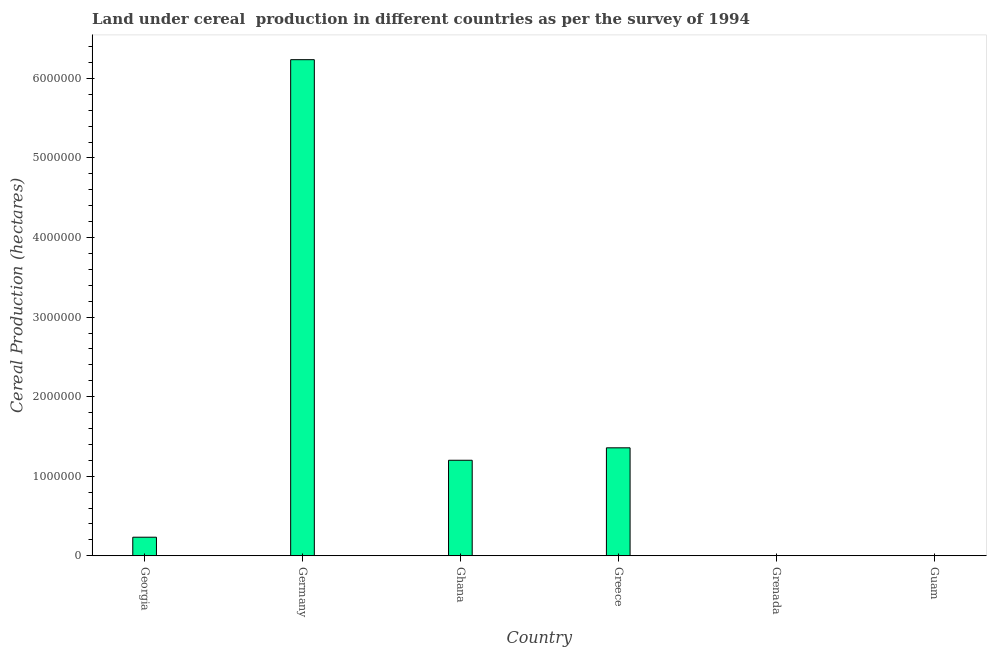Does the graph contain grids?
Provide a short and direct response. No. What is the title of the graph?
Provide a short and direct response. Land under cereal  production in different countries as per the survey of 1994. What is the label or title of the Y-axis?
Provide a succinct answer. Cereal Production (hectares). What is the land under cereal production in Germany?
Ensure brevity in your answer.  6.24e+06. Across all countries, what is the maximum land under cereal production?
Make the answer very short. 6.24e+06. In which country was the land under cereal production maximum?
Your answer should be compact. Germany. In which country was the land under cereal production minimum?
Keep it short and to the point. Guam. What is the sum of the land under cereal production?
Provide a succinct answer. 9.03e+06. What is the difference between the land under cereal production in Georgia and Greece?
Offer a terse response. -1.12e+06. What is the average land under cereal production per country?
Provide a short and direct response. 1.50e+06. What is the median land under cereal production?
Keep it short and to the point. 7.17e+05. What is the ratio of the land under cereal production in Germany to that in Guam?
Provide a succinct answer. 7.79e+05. Is the difference between the land under cereal production in Grenada and Guam greater than the difference between any two countries?
Offer a terse response. No. What is the difference between the highest and the second highest land under cereal production?
Give a very brief answer. 4.88e+06. What is the difference between the highest and the lowest land under cereal production?
Keep it short and to the point. 6.24e+06. How many bars are there?
Provide a succinct answer. 6. Are all the bars in the graph horizontal?
Make the answer very short. No. How many countries are there in the graph?
Offer a terse response. 6. What is the Cereal Production (hectares) of Georgia?
Make the answer very short. 2.34e+05. What is the Cereal Production (hectares) of Germany?
Ensure brevity in your answer.  6.24e+06. What is the Cereal Production (hectares) in Ghana?
Ensure brevity in your answer.  1.20e+06. What is the Cereal Production (hectares) in Greece?
Your answer should be very brief. 1.36e+06. What is the Cereal Production (hectares) of Grenada?
Keep it short and to the point. 350. What is the difference between the Cereal Production (hectares) in Georgia and Germany?
Make the answer very short. -6.00e+06. What is the difference between the Cereal Production (hectares) in Georgia and Ghana?
Make the answer very short. -9.67e+05. What is the difference between the Cereal Production (hectares) in Georgia and Greece?
Ensure brevity in your answer.  -1.12e+06. What is the difference between the Cereal Production (hectares) in Georgia and Grenada?
Provide a short and direct response. 2.33e+05. What is the difference between the Cereal Production (hectares) in Georgia and Guam?
Offer a terse response. 2.33e+05. What is the difference between the Cereal Production (hectares) in Germany and Ghana?
Ensure brevity in your answer.  5.03e+06. What is the difference between the Cereal Production (hectares) in Germany and Greece?
Your answer should be compact. 4.88e+06. What is the difference between the Cereal Production (hectares) in Germany and Grenada?
Offer a terse response. 6.23e+06. What is the difference between the Cereal Production (hectares) in Germany and Guam?
Ensure brevity in your answer.  6.24e+06. What is the difference between the Cereal Production (hectares) in Ghana and Greece?
Offer a terse response. -1.56e+05. What is the difference between the Cereal Production (hectares) in Ghana and Grenada?
Offer a terse response. 1.20e+06. What is the difference between the Cereal Production (hectares) in Ghana and Guam?
Provide a succinct answer. 1.20e+06. What is the difference between the Cereal Production (hectares) in Greece and Grenada?
Provide a succinct answer. 1.36e+06. What is the difference between the Cereal Production (hectares) in Greece and Guam?
Your response must be concise. 1.36e+06. What is the difference between the Cereal Production (hectares) in Grenada and Guam?
Your answer should be compact. 342. What is the ratio of the Cereal Production (hectares) in Georgia to that in Germany?
Your answer should be very brief. 0.04. What is the ratio of the Cereal Production (hectares) in Georgia to that in Ghana?
Provide a short and direct response. 0.19. What is the ratio of the Cereal Production (hectares) in Georgia to that in Greece?
Give a very brief answer. 0.17. What is the ratio of the Cereal Production (hectares) in Georgia to that in Grenada?
Make the answer very short. 667.15. What is the ratio of the Cereal Production (hectares) in Georgia to that in Guam?
Give a very brief answer. 2.92e+04. What is the ratio of the Cereal Production (hectares) in Germany to that in Ghana?
Your answer should be compact. 5.19. What is the ratio of the Cereal Production (hectares) in Germany to that in Greece?
Offer a very short reply. 4.59. What is the ratio of the Cereal Production (hectares) in Germany to that in Grenada?
Offer a terse response. 1.78e+04. What is the ratio of the Cereal Production (hectares) in Germany to that in Guam?
Keep it short and to the point. 7.79e+05. What is the ratio of the Cereal Production (hectares) in Ghana to that in Greece?
Your response must be concise. 0.89. What is the ratio of the Cereal Production (hectares) in Ghana to that in Grenada?
Provide a succinct answer. 3430.57. What is the ratio of the Cereal Production (hectares) in Ghana to that in Guam?
Your response must be concise. 1.50e+05. What is the ratio of the Cereal Production (hectares) in Greece to that in Grenada?
Offer a terse response. 3877.15. What is the ratio of the Cereal Production (hectares) in Greece to that in Guam?
Your response must be concise. 1.70e+05. What is the ratio of the Cereal Production (hectares) in Grenada to that in Guam?
Make the answer very short. 43.75. 